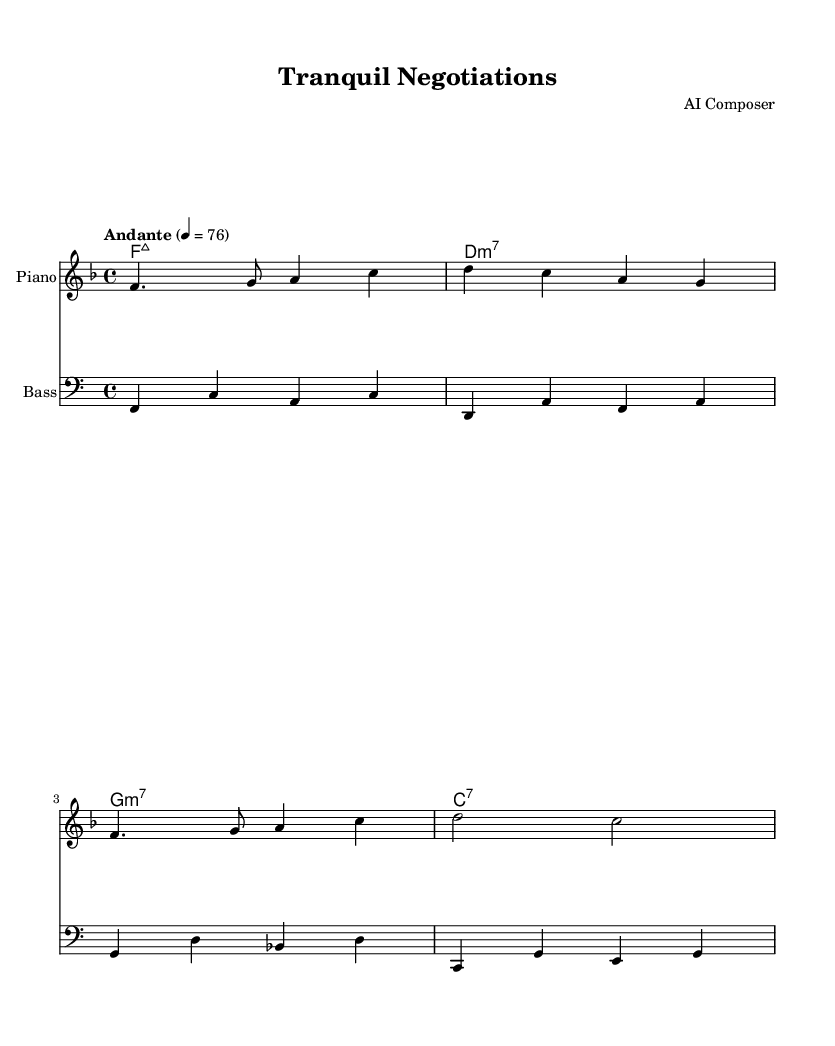What is the key signature of this music? The key signature is F major, which has one flat (B flat). This can be identified from the key signature positioned at the beginning of the staff, indicating the notes in the piece will predominantly belong to the F major scale.
Answer: F major What is the time signature of the music? The time signature is 4/4, which is indicated at the beginning of the score. This means there are four beats in each measure and the quarter note receives one beat.
Answer: 4/4 What is the tempo marking for this piece? The tempo marking is "Andante," which indicates a moderate walking pace for the music. This is seen in the tempo indication written above the staff.
Answer: Andante What is the first chord in the harmonies? The first chord in the harmonies is F major 7. It is notated as "F:maj7" in the chord mode section, indicating the root is F with a major seventh.
Answer: F:maj7 How many measures are in the melody section? There are four measures in the melody section, as indicated by the grouping of notes and the vertical bar lines separating each measure. Counting each section between the bar lines confirms this count.
Answer: 4 What is the structure of the bass line in relation to melody? The bass line accompanies the melody by playing a lower pitch that complements the harmonic structure, typically providing the root notes of the chords. Each bass note corresponds to the harmonic progression noted above, reinforcing the melodic line.
Answer: Complementary What genre of music does this sheet represent? This sheet represents classic bossa nova, which is a genre of Brazilian music characterized by its smooth and relaxed style, often incorporating syncopated rhythms and harmonies typical of jazz. The overall feel and harmonic choices reflect this genre.
Answer: Bossa nova 